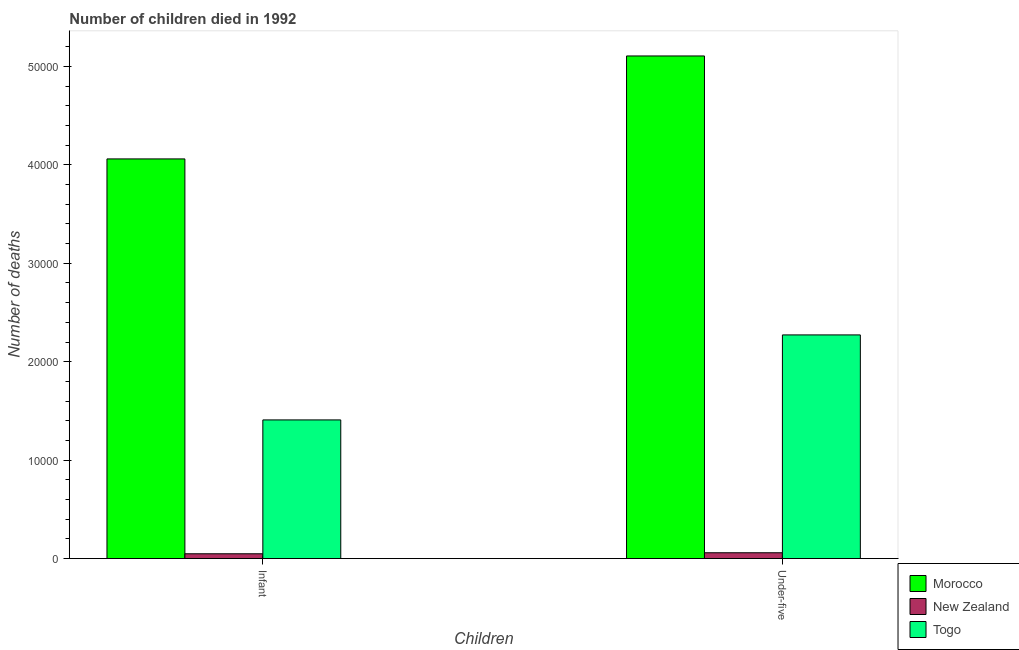Are the number of bars on each tick of the X-axis equal?
Keep it short and to the point. Yes. How many bars are there on the 2nd tick from the left?
Make the answer very short. 3. How many bars are there on the 1st tick from the right?
Provide a short and direct response. 3. What is the label of the 2nd group of bars from the left?
Ensure brevity in your answer.  Under-five. What is the number of infant deaths in Morocco?
Ensure brevity in your answer.  4.06e+04. Across all countries, what is the maximum number of infant deaths?
Keep it short and to the point. 4.06e+04. Across all countries, what is the minimum number of infant deaths?
Offer a terse response. 487. In which country was the number of infant deaths maximum?
Keep it short and to the point. Morocco. In which country was the number of infant deaths minimum?
Provide a short and direct response. New Zealand. What is the total number of infant deaths in the graph?
Provide a short and direct response. 5.52e+04. What is the difference between the number of under-five deaths in Morocco and that in New Zealand?
Ensure brevity in your answer.  5.05e+04. What is the difference between the number of under-five deaths in Morocco and the number of infant deaths in New Zealand?
Offer a terse response. 5.06e+04. What is the average number of under-five deaths per country?
Your answer should be very brief. 2.48e+04. What is the difference between the number of infant deaths and number of under-five deaths in Morocco?
Give a very brief answer. -1.05e+04. In how many countries, is the number of under-five deaths greater than 20000 ?
Offer a very short reply. 2. What is the ratio of the number of infant deaths in Togo to that in Morocco?
Offer a terse response. 0.35. Is the number of under-five deaths in Togo less than that in New Zealand?
Provide a short and direct response. No. In how many countries, is the number of under-five deaths greater than the average number of under-five deaths taken over all countries?
Your answer should be very brief. 1. What does the 3rd bar from the left in Under-five represents?
Offer a terse response. Togo. What does the 2nd bar from the right in Infant represents?
Provide a short and direct response. New Zealand. Are all the bars in the graph horizontal?
Give a very brief answer. No. Does the graph contain any zero values?
Your answer should be very brief. No. Does the graph contain grids?
Offer a terse response. No. What is the title of the graph?
Your answer should be very brief. Number of children died in 1992. Does "Cabo Verde" appear as one of the legend labels in the graph?
Provide a short and direct response. No. What is the label or title of the X-axis?
Your response must be concise. Children. What is the label or title of the Y-axis?
Give a very brief answer. Number of deaths. What is the Number of deaths in Morocco in Infant?
Keep it short and to the point. 4.06e+04. What is the Number of deaths in New Zealand in Infant?
Offer a terse response. 487. What is the Number of deaths of Togo in Infant?
Provide a succinct answer. 1.41e+04. What is the Number of deaths of Morocco in Under-five?
Ensure brevity in your answer.  5.11e+04. What is the Number of deaths of New Zealand in Under-five?
Offer a terse response. 591. What is the Number of deaths of Togo in Under-five?
Ensure brevity in your answer.  2.27e+04. Across all Children, what is the maximum Number of deaths in Morocco?
Offer a terse response. 5.11e+04. Across all Children, what is the maximum Number of deaths in New Zealand?
Offer a very short reply. 591. Across all Children, what is the maximum Number of deaths in Togo?
Keep it short and to the point. 2.27e+04. Across all Children, what is the minimum Number of deaths in Morocco?
Make the answer very short. 4.06e+04. Across all Children, what is the minimum Number of deaths in New Zealand?
Make the answer very short. 487. Across all Children, what is the minimum Number of deaths of Togo?
Ensure brevity in your answer.  1.41e+04. What is the total Number of deaths of Morocco in the graph?
Offer a very short reply. 9.17e+04. What is the total Number of deaths of New Zealand in the graph?
Keep it short and to the point. 1078. What is the total Number of deaths of Togo in the graph?
Provide a short and direct response. 3.68e+04. What is the difference between the Number of deaths in Morocco in Infant and that in Under-five?
Offer a terse response. -1.05e+04. What is the difference between the Number of deaths in New Zealand in Infant and that in Under-five?
Your answer should be compact. -104. What is the difference between the Number of deaths in Togo in Infant and that in Under-five?
Offer a terse response. -8636. What is the difference between the Number of deaths in Morocco in Infant and the Number of deaths in New Zealand in Under-five?
Provide a short and direct response. 4.00e+04. What is the difference between the Number of deaths in Morocco in Infant and the Number of deaths in Togo in Under-five?
Your answer should be compact. 1.79e+04. What is the difference between the Number of deaths in New Zealand in Infant and the Number of deaths in Togo in Under-five?
Provide a succinct answer. -2.22e+04. What is the average Number of deaths in Morocco per Children?
Provide a succinct answer. 4.58e+04. What is the average Number of deaths of New Zealand per Children?
Ensure brevity in your answer.  539. What is the average Number of deaths of Togo per Children?
Ensure brevity in your answer.  1.84e+04. What is the difference between the Number of deaths in Morocco and Number of deaths in New Zealand in Infant?
Provide a short and direct response. 4.01e+04. What is the difference between the Number of deaths in Morocco and Number of deaths in Togo in Infant?
Give a very brief answer. 2.65e+04. What is the difference between the Number of deaths of New Zealand and Number of deaths of Togo in Infant?
Ensure brevity in your answer.  -1.36e+04. What is the difference between the Number of deaths in Morocco and Number of deaths in New Zealand in Under-five?
Make the answer very short. 5.05e+04. What is the difference between the Number of deaths in Morocco and Number of deaths in Togo in Under-five?
Your answer should be compact. 2.83e+04. What is the difference between the Number of deaths of New Zealand and Number of deaths of Togo in Under-five?
Offer a very short reply. -2.21e+04. What is the ratio of the Number of deaths in Morocco in Infant to that in Under-five?
Offer a very short reply. 0.8. What is the ratio of the Number of deaths of New Zealand in Infant to that in Under-five?
Offer a very short reply. 0.82. What is the ratio of the Number of deaths of Togo in Infant to that in Under-five?
Your response must be concise. 0.62. What is the difference between the highest and the second highest Number of deaths of Morocco?
Keep it short and to the point. 1.05e+04. What is the difference between the highest and the second highest Number of deaths in New Zealand?
Your answer should be compact. 104. What is the difference between the highest and the second highest Number of deaths of Togo?
Offer a terse response. 8636. What is the difference between the highest and the lowest Number of deaths in Morocco?
Give a very brief answer. 1.05e+04. What is the difference between the highest and the lowest Number of deaths of New Zealand?
Ensure brevity in your answer.  104. What is the difference between the highest and the lowest Number of deaths in Togo?
Your response must be concise. 8636. 